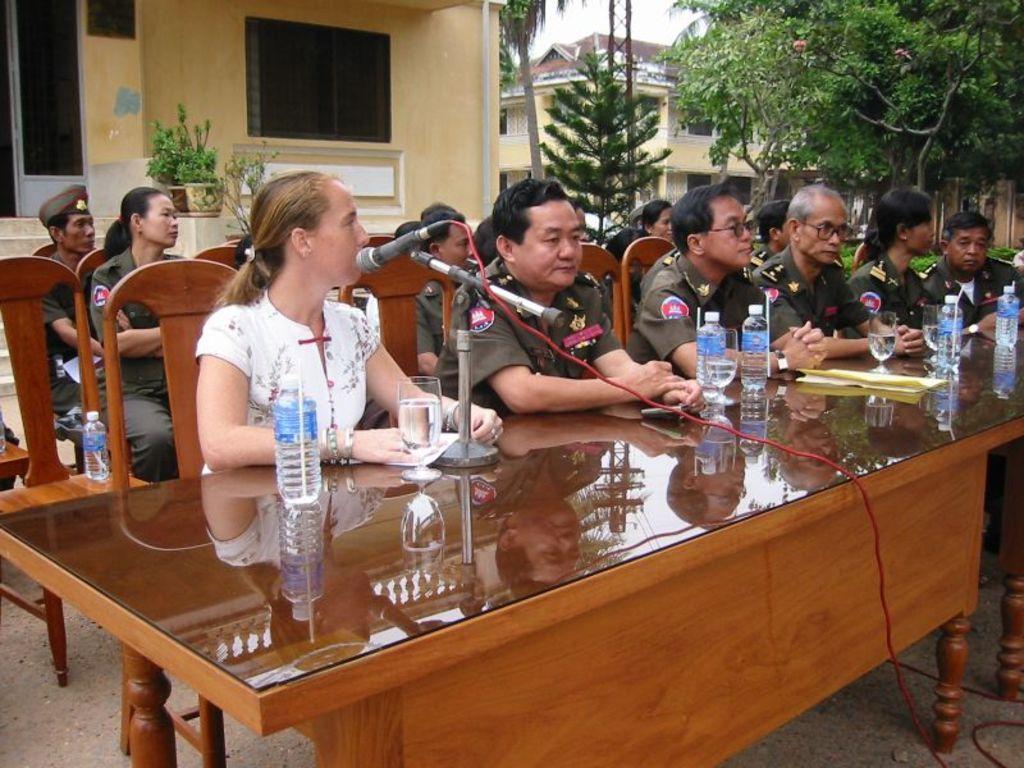How would you summarize this image in a sentence or two? there is a table on which there are bottles and glasses and microphone attached to that. there are chairs on which people are sitting. behind them there is a building and at the right there are trees. 